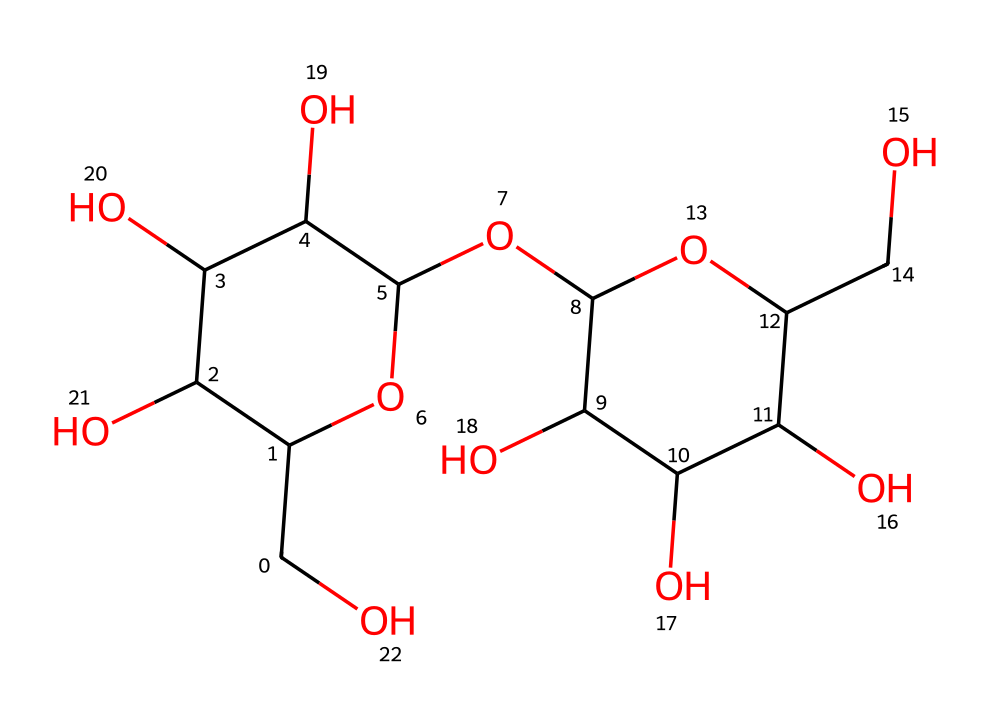What is the molecular formula of this structure? To obtain the molecular formula, count each type of atom in the SMILES representation. The structure consists of carbon (C), hydrogen (H), and oxygen (O) atoms. Counting gives us C12, H22, O11, which forms the formula.
Answer: C12H22O11 How many rings are present in the structure? By analyzing the SMILES representation, we can identify the ring structures. The notation 'C1' and 'C2' indicates the start of cycles. There are two distinct ring systems within this molecule.
Answer: 2 What type of carbohydrate is represented by this structure? The presence of multiple hydroxyl groups (-OH) and a structure with rings suggests this molecule is a polysaccharide, specifically a form of resistant starch. Polysaccharides are carbohydrates made up of long chains of monosaccharide units.
Answer: polysaccharide What is the significance of resistant starch for endurance athletes? Resistant starch acts as a prebiotic, providing benefits such as improved gut health, enhanced glycogen storage, and stable energy release, which are particularly important for endurance athletes during prolonged activity.
Answer: energy source How many hydroxyl groups are present in the structure? To count the hydroxyl groups, observe the -OH functional groups attached to the carbon atoms. There are five hydroxyl groups situated throughout the structure, indicating its hydrophilic nature.
Answer: 5 What does the presence of multiple hydroxyl groups indicate about the solubility of this carbohydrate? The multiple hydroxyl groups enhance the solubility of the carbohydrate in water due to hydrogen bonding, making it more digestible and bioavailable for energy.
Answer: soluble 